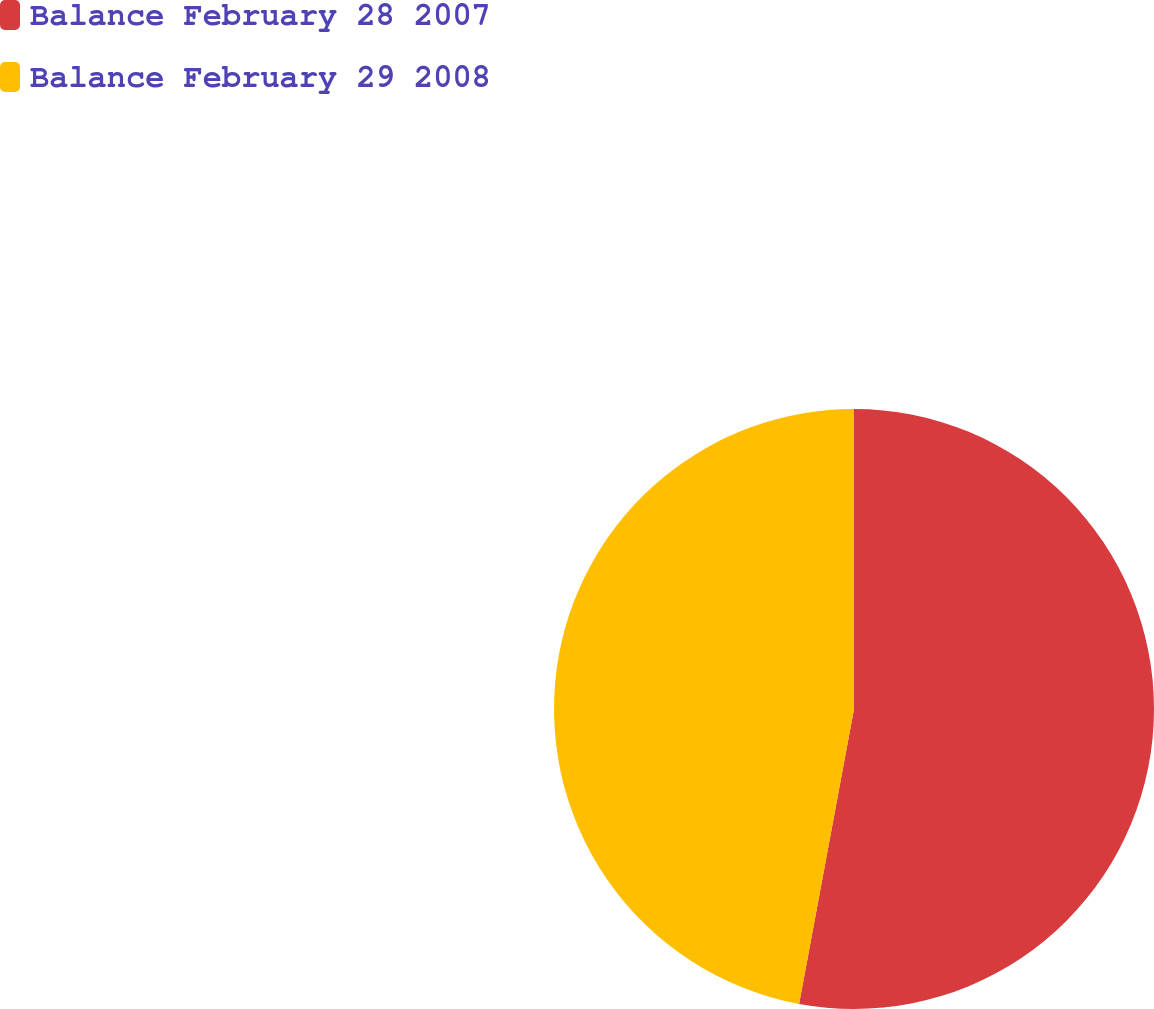Convert chart to OTSL. <chart><loc_0><loc_0><loc_500><loc_500><pie_chart><fcel>Balance February 28 2007<fcel>Balance February 29 2008<nl><fcel>52.93%<fcel>47.07%<nl></chart> 